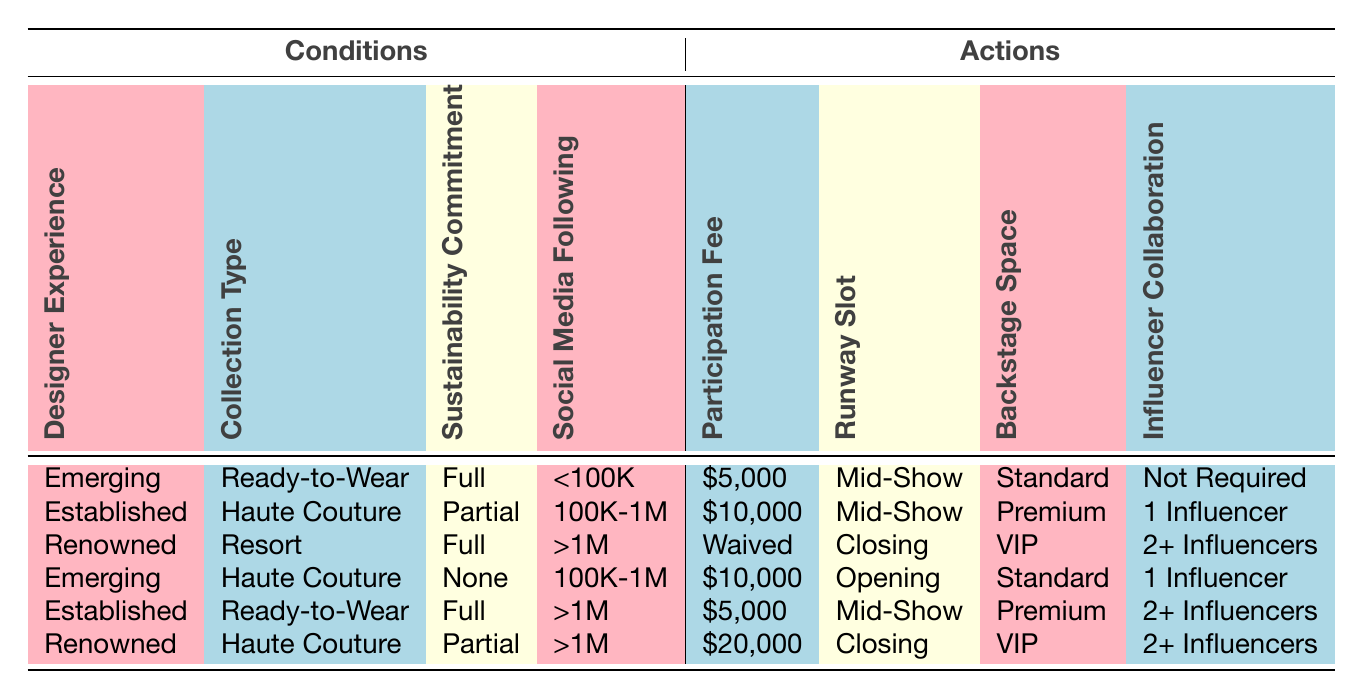What is the participation fee for a renowned designer with a full sustainability commitment and social media following greater than 1M? According to the table, for a renowned designer with full sustainability commitment and a social media following of greater than 1M, the participation fee is waived.
Answer: Waived Which collection type requires the highest participation fee when considering the established designer experience with partial sustainability commitment and 100K-1M social media following? The highest participation fee for an established designer with partial sustainability commitment and a 100K-1M social media following is $10,000, as seen in the corresponding row of the table.
Answer: $10,000 Is it true that all designers with a ‘Full’ sustainability commitment have their participation fees waived? No, not all designers with a full sustainability commitment have their fees waived. For example, emerging designers with a full commitment still have a fee of $5,000.
Answer: No What is the backstage space for an emerging designer who presents a ready-to-wear collection without any sustainability commitment and has a social media following less than 100K? The table indicates that for an emerging designer presenting a ready-to-wear collection with no sustainability commitment and a social media following of less than 100K, the backstage space is standard.
Answer: Standard If an established designer with a ready-to-wear collection and a following of greater than 1M participates, what is the runway slot they receive? Referring to the table, an established designer with a ready-to-wear collection and a social media following greater than 1M would be scheduled for a mid-show runway slot.
Answer: Mid-Show What is the average participation fee for all designers in the table? To find the average, add the participation fees: 5000 + 10000 + 0 + 10000 + 5000 + 20000 = 50000. There are 6 entries, so the average is 50000/6 = 8333.33.
Answer: 8333.33 How many influencers must a renowned designer with a haute couture collection and a partial sustainability commitment have for participation? The table shows that a renowned designer with a haute couture collection and a partial sustainability commitment needs to collaborate with 2 or more influencers.
Answer: 2+ Influencers Is there a participation fee for any designer categorized as emerging who presents an haute couture collection? Yes, there is a participation fee for emerging designers presenting an haute couture collection; it is $10,000 as indicated in the table.
Answer: Yes What is the backstage space designation for an established designer participating in a mid-show slot with a ready-to-wear collection and full sustainability commitment? For an established designer participating in a mid-show slot with a ready-to-wear collection and full sustainability commitment, the backstage space is designated as premium.
Answer: Premium 